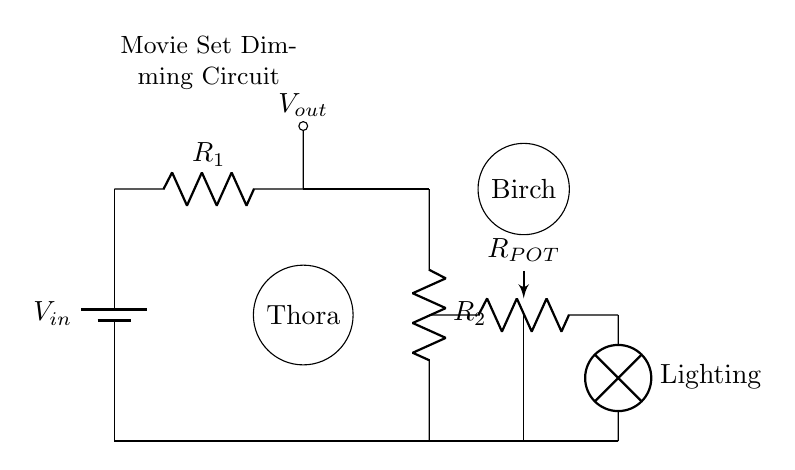What is the type of the main circuit component? The main circuit component is a battery, which is specified at the start of the circuit diagram.
Answer: Battery How many resistors are in the circuit? There are two resistors labeled as R1 and R2 connected in the circuit, identifiable by their positions in the diagram.
Answer: Two What is the function of the potentiometer? The potentiometer is used to adjust the resistance in the circuit, allowing for dimming of the lighting by altering the voltage drop across it.
Answer: Dimming What does Vout represent in the circuit? Vout indicates the output voltage that is delivered to the lighting component, showing where the adjusted voltage can be read from the circuit.
Answer: Output voltage What happens to the lighting intensity if Rpot is increased? Increasing Rpot will raise the resistance, thereby reducing the current flowing through the lighting, which dims the light.
Answer: Dims light What is the purpose of the lamp in the circuit? The lamp acts as the load that utilizes the dimmed voltage from the circuit, functioning as the final output target for the lighting system on the movie set.
Answer: Lighting 